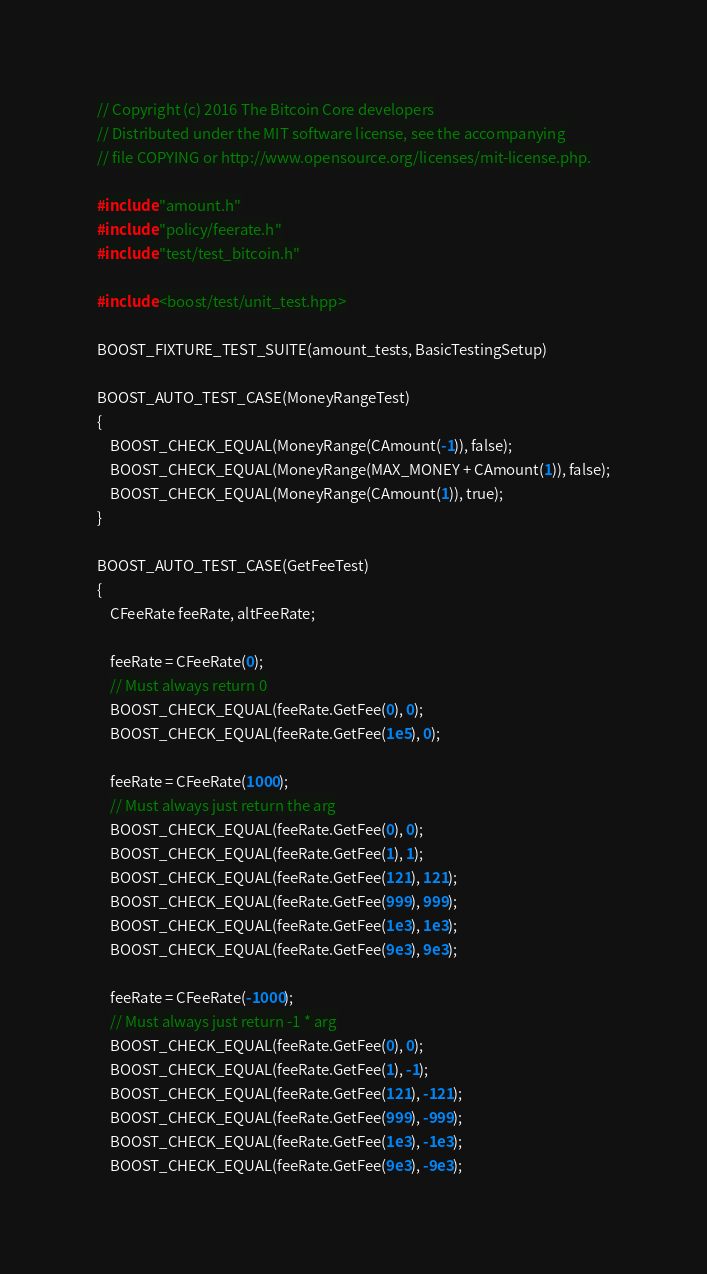<code> <loc_0><loc_0><loc_500><loc_500><_C++_>// Copyright (c) 2016 The Bitcoin Core developers
// Distributed under the MIT software license, see the accompanying
// file COPYING or http://www.opensource.org/licenses/mit-license.php.

#include "amount.h"
#include "policy/feerate.h"
#include "test/test_bitcoin.h"

#include <boost/test/unit_test.hpp>

BOOST_FIXTURE_TEST_SUITE(amount_tests, BasicTestingSetup)

BOOST_AUTO_TEST_CASE(MoneyRangeTest)
{
    BOOST_CHECK_EQUAL(MoneyRange(CAmount(-1)), false);
    BOOST_CHECK_EQUAL(MoneyRange(MAX_MONEY + CAmount(1)), false);
    BOOST_CHECK_EQUAL(MoneyRange(CAmount(1)), true);
}

BOOST_AUTO_TEST_CASE(GetFeeTest)
{
    CFeeRate feeRate, altFeeRate;

    feeRate = CFeeRate(0);
    // Must always return 0
    BOOST_CHECK_EQUAL(feeRate.GetFee(0), 0);
    BOOST_CHECK_EQUAL(feeRate.GetFee(1e5), 0);

    feeRate = CFeeRate(1000);
    // Must always just return the arg
    BOOST_CHECK_EQUAL(feeRate.GetFee(0), 0);
    BOOST_CHECK_EQUAL(feeRate.GetFee(1), 1);
    BOOST_CHECK_EQUAL(feeRate.GetFee(121), 121);
    BOOST_CHECK_EQUAL(feeRate.GetFee(999), 999);
    BOOST_CHECK_EQUAL(feeRate.GetFee(1e3), 1e3);
    BOOST_CHECK_EQUAL(feeRate.GetFee(9e3), 9e3);

    feeRate = CFeeRate(-1000);
    // Must always just return -1 * arg
    BOOST_CHECK_EQUAL(feeRate.GetFee(0), 0);
    BOOST_CHECK_EQUAL(feeRate.GetFee(1), -1);
    BOOST_CHECK_EQUAL(feeRate.GetFee(121), -121);
    BOOST_CHECK_EQUAL(feeRate.GetFee(999), -999);
    BOOST_CHECK_EQUAL(feeRate.GetFee(1e3), -1e3);
    BOOST_CHECK_EQUAL(feeRate.GetFee(9e3), -9e3);
</code> 